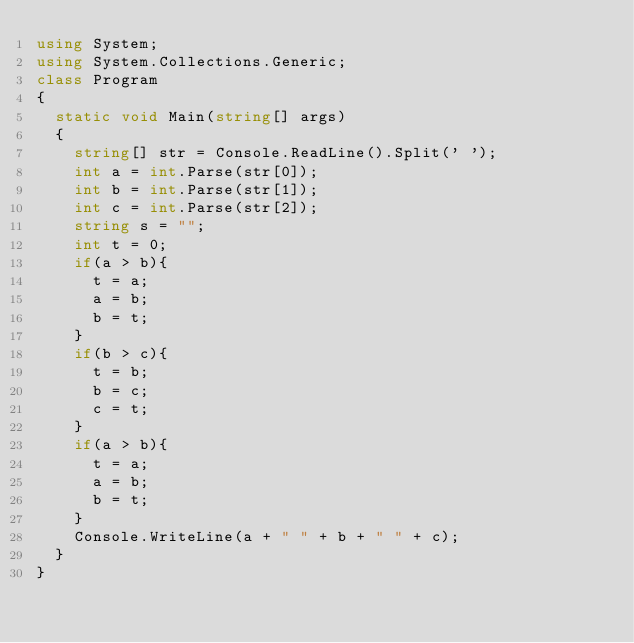<code> <loc_0><loc_0><loc_500><loc_500><_C#_>using System;
using System.Collections.Generic;
class Program
{
	static void Main(string[] args)
	{
		string[] str = Console.ReadLine().Split(' ');
		int a = int.Parse(str[0]);
		int b = int.Parse(str[1]);
		int c = int.Parse(str[2]);
		string s = "";
		int t = 0;
		if(a > b){
			t = a;
			a = b;
			b = t;
		}
		if(b > c){
			t = b;
			b = c;
			c = t;
		}
		if(a > b){
			t = a;
			a = b;
			b = t;
		}
		Console.WriteLine(a + " " + b + " " + c);
	}
}
</code> 